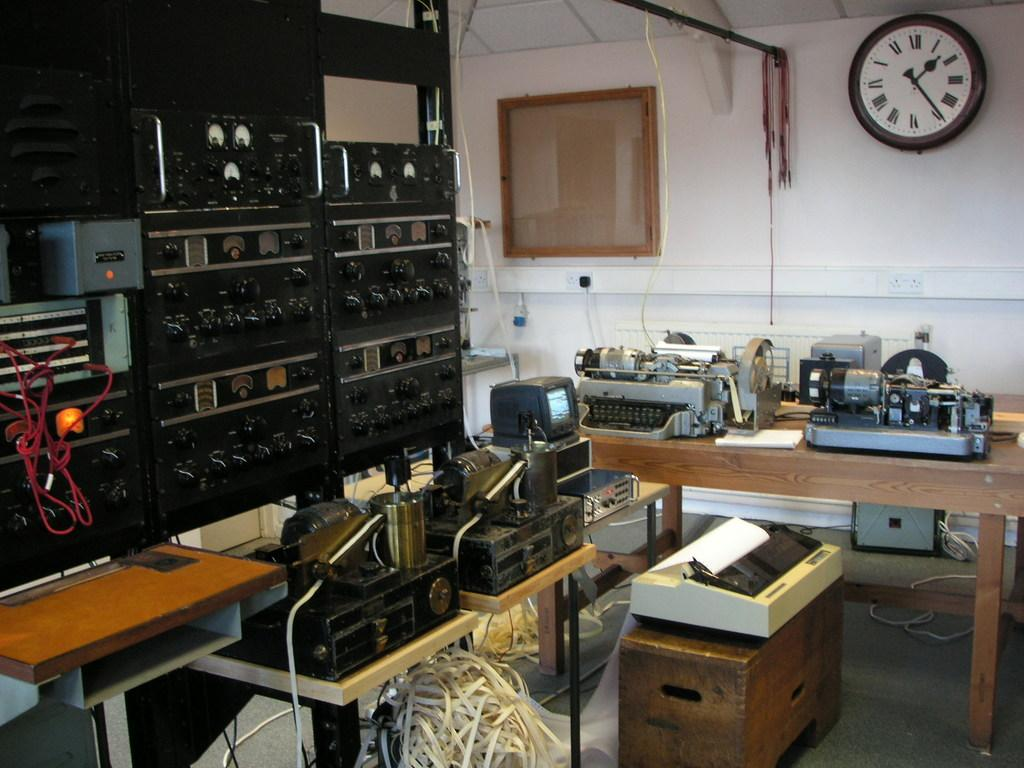What can be seen in the middle of the image? There are machines in the middle of the image. Where is the wall clock located in the image? The wall clock is in the top right hand side of the image. What is hanging on the wall in the background of the image? There is a glass frame on the wall in the background of the image. What type of pest can be seen crawling on the machines in the image? There are no pests visible in the image; it only features machines, a wall clock, and a glass frame. What authority figure is present in the image? There is no authority figure present in the image. 